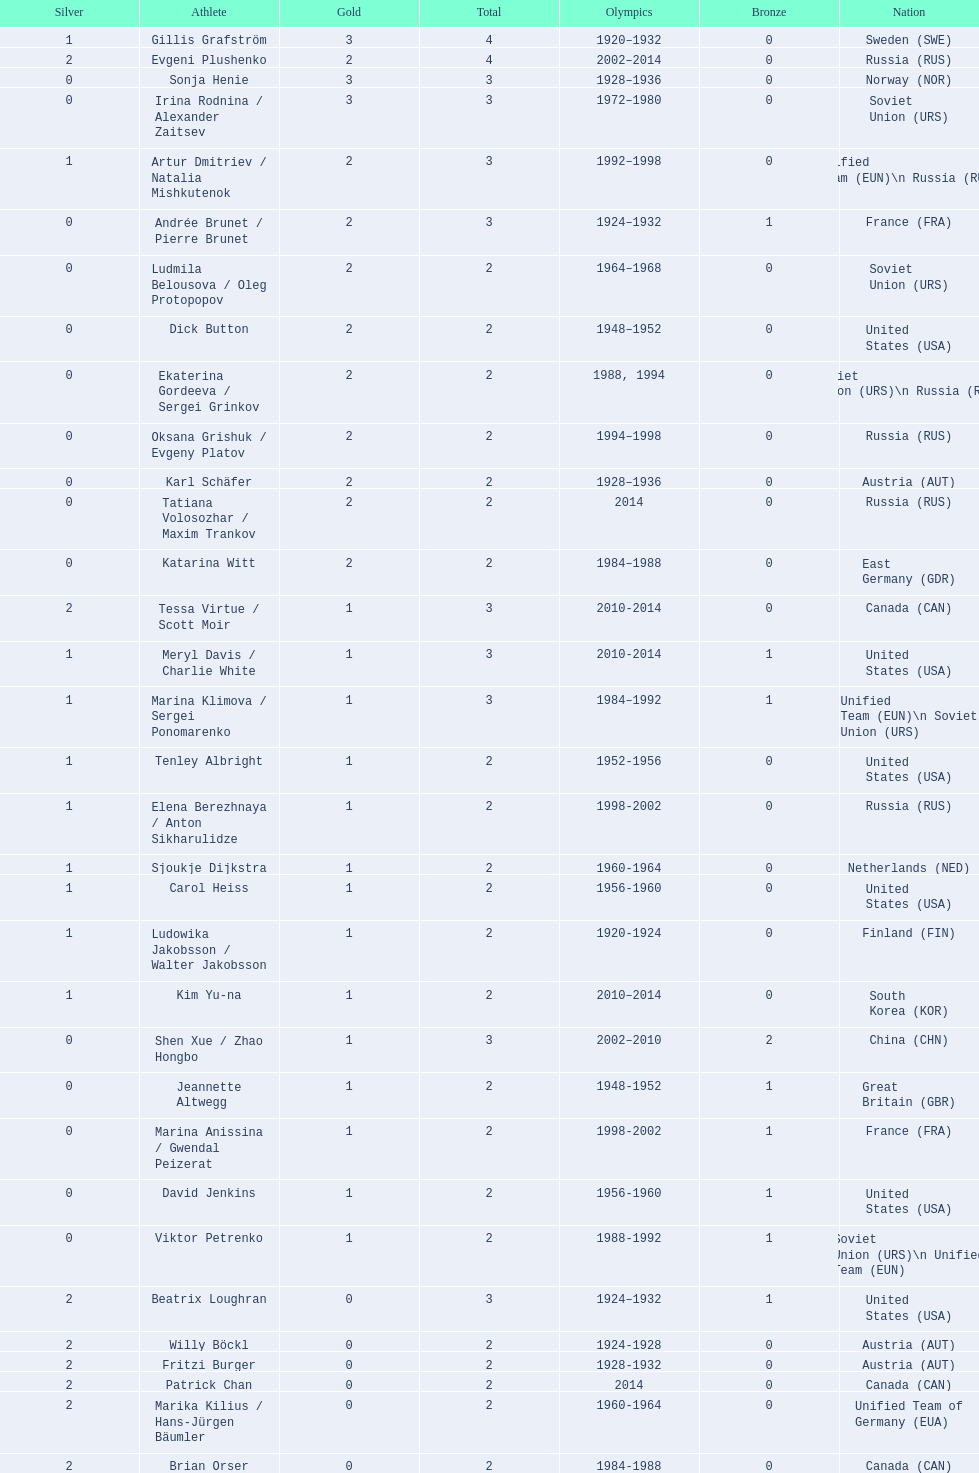Which nation was the first to win three gold medals for olympic figure skating? Sweden. 